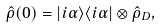Convert formula to latex. <formula><loc_0><loc_0><loc_500><loc_500>\hat { \rho } ( 0 ) = | i \alpha \rangle \langle i \alpha | \otimes \hat { \rho } _ { D } ,</formula> 